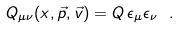<formula> <loc_0><loc_0><loc_500><loc_500>Q _ { \mu \nu } ( x , \vec { p } , \vec { v } ) = Q \, \epsilon _ { \mu } \epsilon _ { \nu } \ .</formula> 